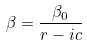<formula> <loc_0><loc_0><loc_500><loc_500>\beta = \frac { \beta _ { 0 } } { r - i c }</formula> 